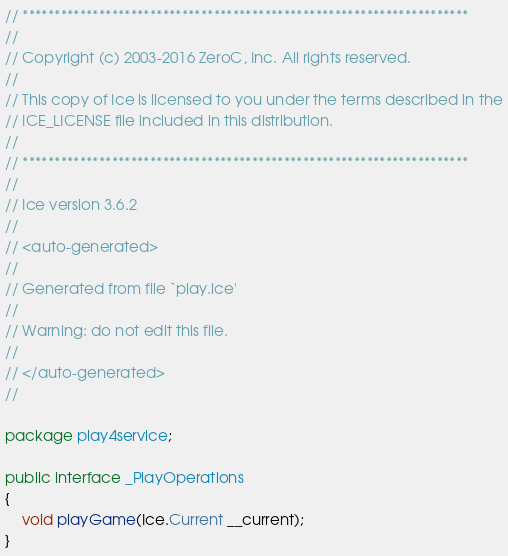Convert code to text. <code><loc_0><loc_0><loc_500><loc_500><_Java_>// **********************************************************************
//
// Copyright (c) 2003-2016 ZeroC, Inc. All rights reserved.
//
// This copy of Ice is licensed to you under the terms described in the
// ICE_LICENSE file included in this distribution.
//
// **********************************************************************
//
// Ice version 3.6.2
//
// <auto-generated>
//
// Generated from file `play.ice'
//
// Warning: do not edit this file.
//
// </auto-generated>
//

package play4service;

public interface _PlayOperations
{
    void playGame(Ice.Current __current);
}
</code> 